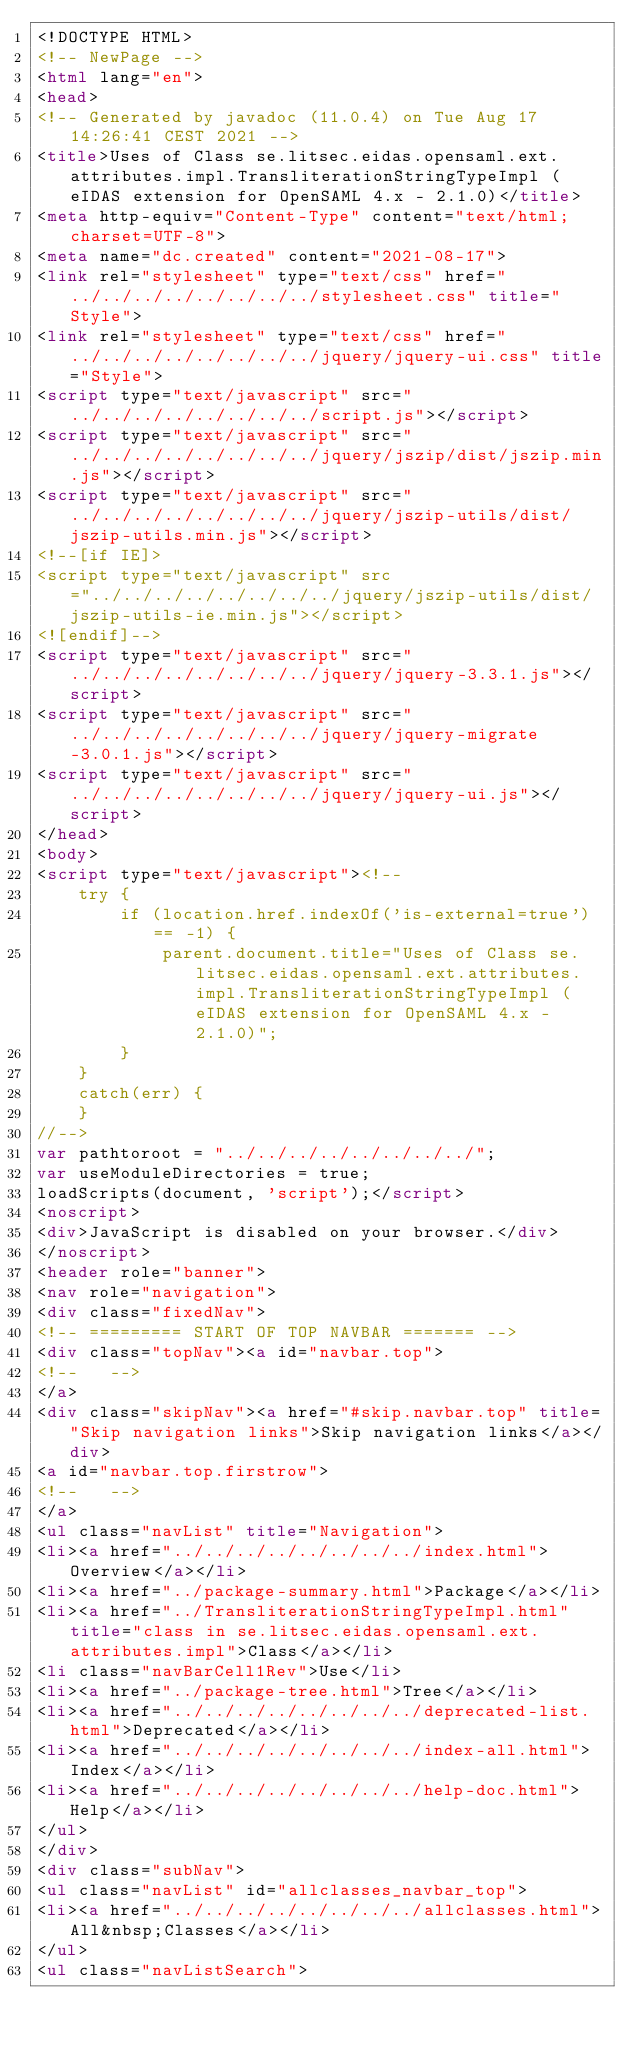<code> <loc_0><loc_0><loc_500><loc_500><_HTML_><!DOCTYPE HTML>
<!-- NewPage -->
<html lang="en">
<head>
<!-- Generated by javadoc (11.0.4) on Tue Aug 17 14:26:41 CEST 2021 -->
<title>Uses of Class se.litsec.eidas.opensaml.ext.attributes.impl.TransliterationStringTypeImpl (eIDAS extension for OpenSAML 4.x - 2.1.0)</title>
<meta http-equiv="Content-Type" content="text/html; charset=UTF-8">
<meta name="dc.created" content="2021-08-17">
<link rel="stylesheet" type="text/css" href="../../../../../../../../stylesheet.css" title="Style">
<link rel="stylesheet" type="text/css" href="../../../../../../../../jquery/jquery-ui.css" title="Style">
<script type="text/javascript" src="../../../../../../../../script.js"></script>
<script type="text/javascript" src="../../../../../../../../jquery/jszip/dist/jszip.min.js"></script>
<script type="text/javascript" src="../../../../../../../../jquery/jszip-utils/dist/jszip-utils.min.js"></script>
<!--[if IE]>
<script type="text/javascript" src="../../../../../../../../jquery/jszip-utils/dist/jszip-utils-ie.min.js"></script>
<![endif]-->
<script type="text/javascript" src="../../../../../../../../jquery/jquery-3.3.1.js"></script>
<script type="text/javascript" src="../../../../../../../../jquery/jquery-migrate-3.0.1.js"></script>
<script type="text/javascript" src="../../../../../../../../jquery/jquery-ui.js"></script>
</head>
<body>
<script type="text/javascript"><!--
    try {
        if (location.href.indexOf('is-external=true') == -1) {
            parent.document.title="Uses of Class se.litsec.eidas.opensaml.ext.attributes.impl.TransliterationStringTypeImpl (eIDAS extension for OpenSAML 4.x - 2.1.0)";
        }
    }
    catch(err) {
    }
//-->
var pathtoroot = "../../../../../../../../";
var useModuleDirectories = true;
loadScripts(document, 'script');</script>
<noscript>
<div>JavaScript is disabled on your browser.</div>
</noscript>
<header role="banner">
<nav role="navigation">
<div class="fixedNav">
<!-- ========= START OF TOP NAVBAR ======= -->
<div class="topNav"><a id="navbar.top">
<!--   -->
</a>
<div class="skipNav"><a href="#skip.navbar.top" title="Skip navigation links">Skip navigation links</a></div>
<a id="navbar.top.firstrow">
<!--   -->
</a>
<ul class="navList" title="Navigation">
<li><a href="../../../../../../../../index.html">Overview</a></li>
<li><a href="../package-summary.html">Package</a></li>
<li><a href="../TransliterationStringTypeImpl.html" title="class in se.litsec.eidas.opensaml.ext.attributes.impl">Class</a></li>
<li class="navBarCell1Rev">Use</li>
<li><a href="../package-tree.html">Tree</a></li>
<li><a href="../../../../../../../../deprecated-list.html">Deprecated</a></li>
<li><a href="../../../../../../../../index-all.html">Index</a></li>
<li><a href="../../../../../../../../help-doc.html">Help</a></li>
</ul>
</div>
<div class="subNav">
<ul class="navList" id="allclasses_navbar_top">
<li><a href="../../../../../../../../allclasses.html">All&nbsp;Classes</a></li>
</ul>
<ul class="navListSearch"></code> 